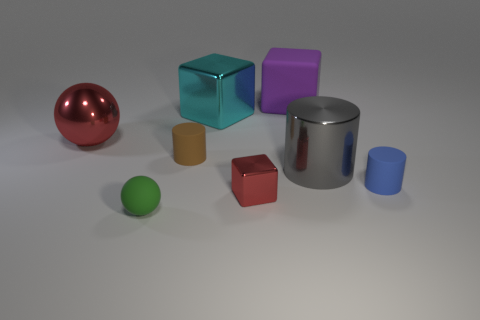Subtract all large blocks. How many blocks are left? 1 Add 2 large purple things. How many objects exist? 10 Subtract all blocks. How many objects are left? 5 Subtract 1 spheres. How many spheres are left? 1 Subtract all green spheres. How many spheres are left? 1 Subtract 0 purple balls. How many objects are left? 8 Subtract all purple cylinders. Subtract all purple balls. How many cylinders are left? 3 Subtract all gray cylinders. How many purple cubes are left? 1 Subtract all small matte cylinders. Subtract all large gray metal cylinders. How many objects are left? 5 Add 2 small red metallic things. How many small red metallic things are left? 3 